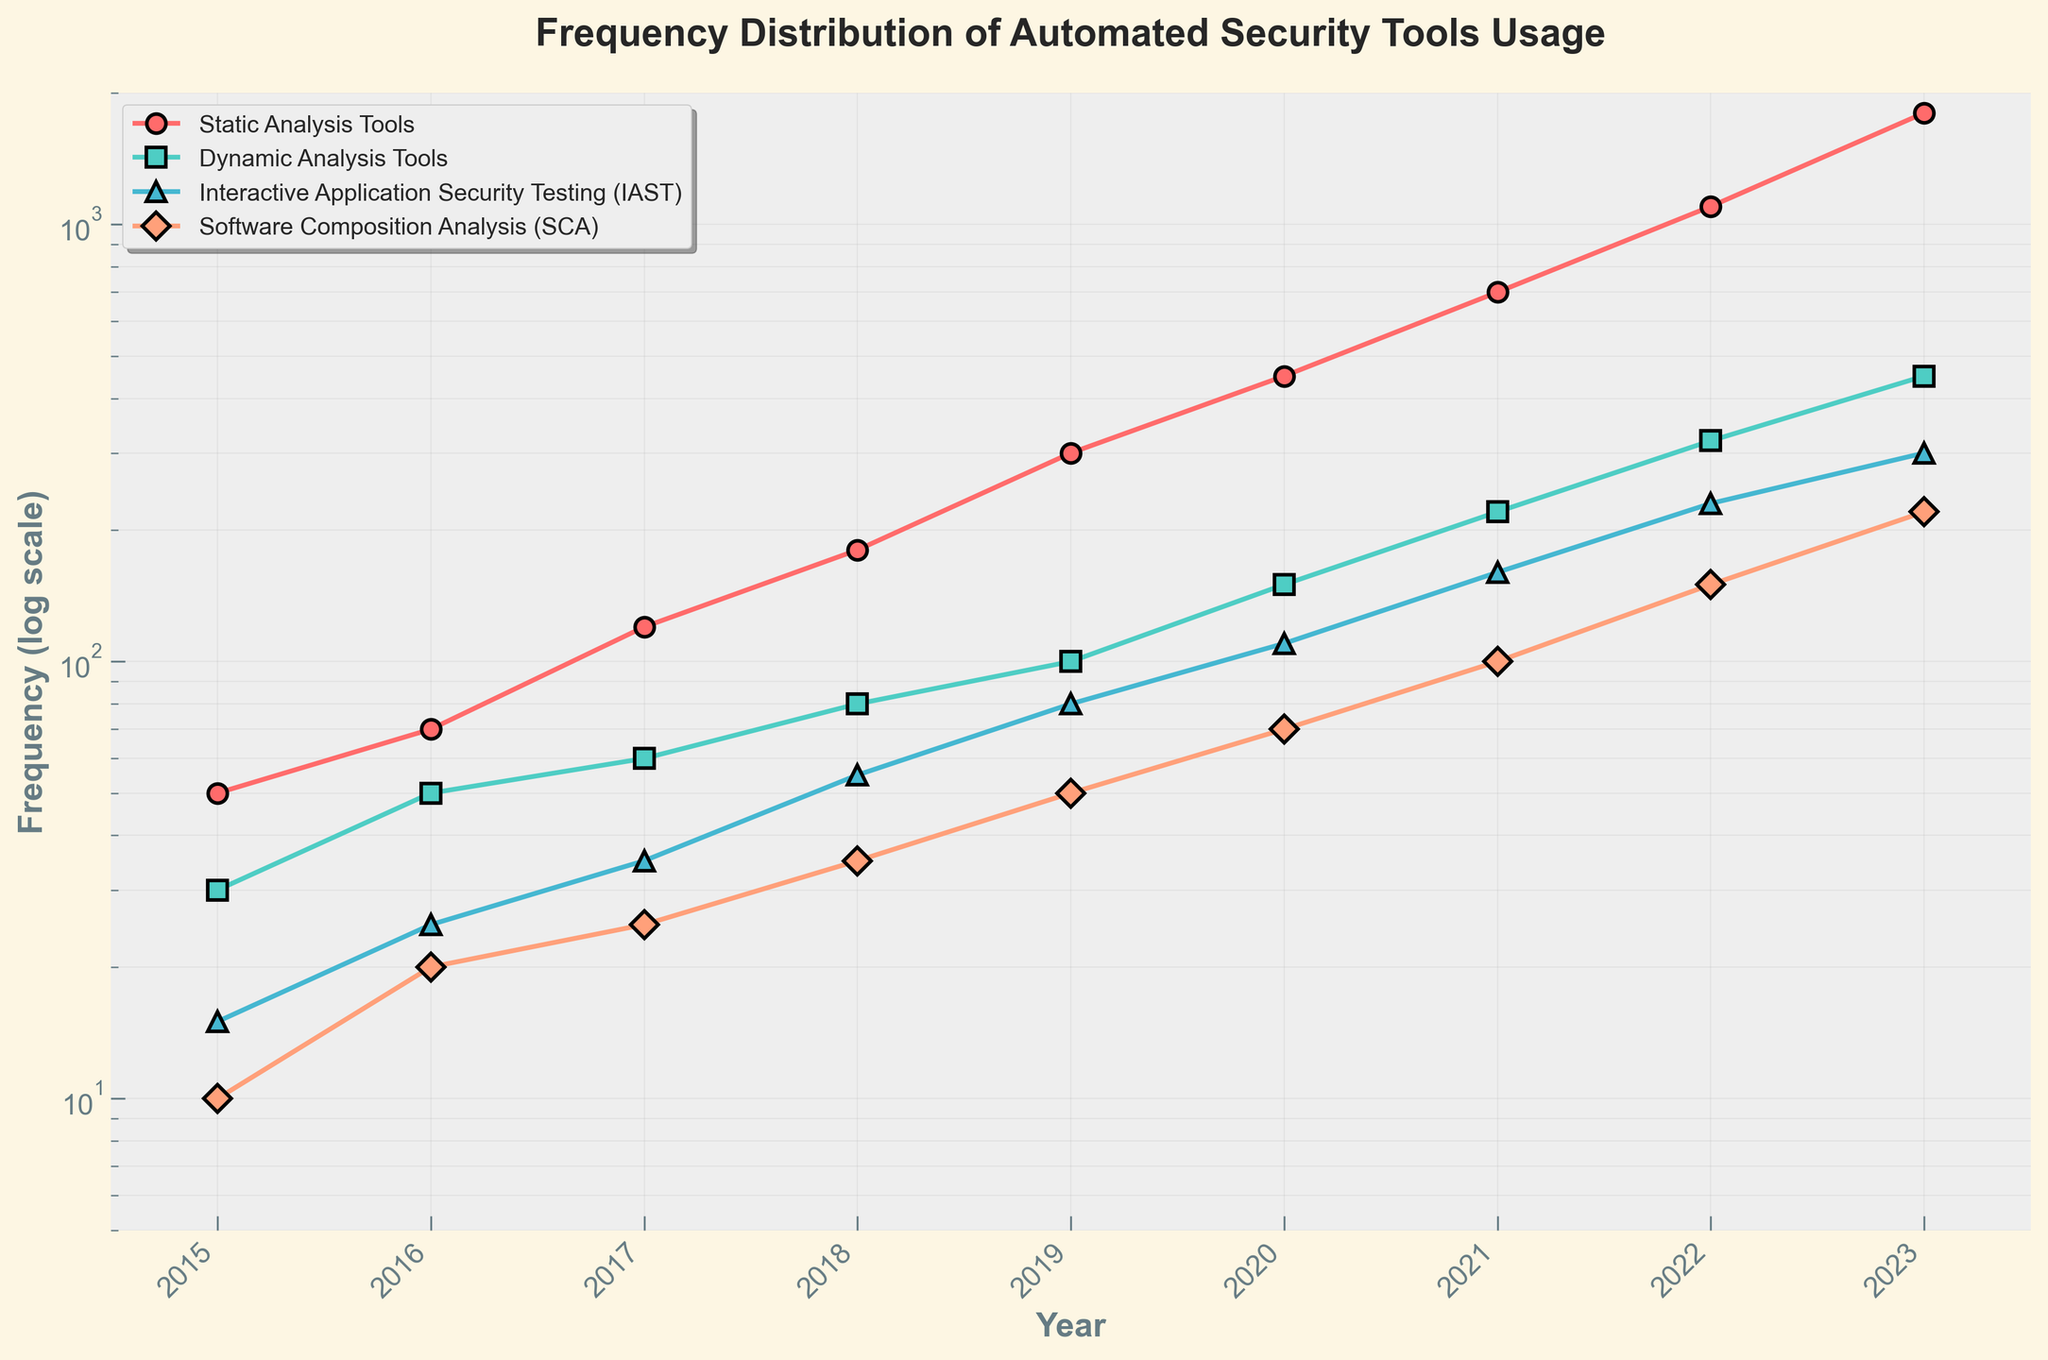What's the title of the plot? The title is typically at the top of the figure and provides a brief description of what the plot depicts. In this case, the title can be read directly from the figure.
Answer: "Frequency Distribution of Automated Security Tools Usage" How is the y-axis scaled in this plot? By examining the y-axis labels, which increase exponentially, it is clear that a log scale is used for depicting the frequency.
Answer: Logarithmic scale What's the frequency of usage for "Dynamic Analysis Tools" in 2017? Locate the point on the "Dynamic Analysis Tools" line that corresponds to the year 2017 and note the y-axis value.
Answer: 60 Which tool category showed the steepest growth between 2015 and 2023? To determine steepest growth, compare the slopes of the different lines over the time period. The steeper the slope, the faster the growth.
Answer: Static Analysis Tools How many years are plotted on the x-axis? Count the year tick marks along the x-axis from start to end. The range is from 2015 to 2023.
Answer: 9 Which tool category had the lowest frequency in 2015? Locate the data points for all tool categories in 2015 and identify the one with the smallest value.
Answer: Software Composition Analysis (SCA) What is the average frequency of "Interactive Application Security Testing (IAST)" over all the years shown? Sum the frequencies of "Interactive Application Security Testing (IAST)" for all years and divide by the number of years.
Answer: (15 + 25 + 35 + 55 + 80 + 110 + 160 + 230 + 300) / 9 = 112.22 In which year did "Static Analysis Tools" usage first exceed 1000? Identify the year on the "Static Analysis Tools" line where the y-value first surpasses 1000.
Answer: 2022 How does the frequency of "Software Composition Analysis (SCA)" in 2023 compare to "Dynamic Analysis Tools" in the same year? Observe the data points for both tool categories in 2023 and compare their y-values.
Answer: 220 vs 450 Between which consecutive years did "Static Analysis Tools" usage experience the largest increase? Calculate the year-on-year differences for "Static Analysis Tools" and identify the highest increment.
Answer: Between 2022 and 2023 